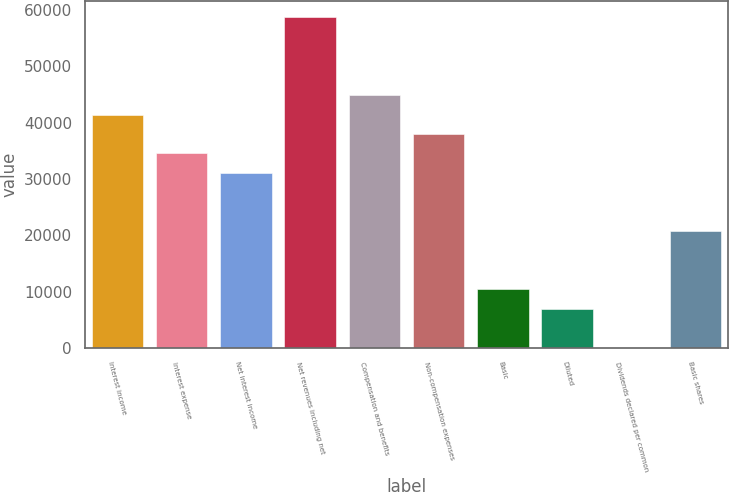<chart> <loc_0><loc_0><loc_500><loc_500><bar_chart><fcel>Interest income<fcel>Interest expense<fcel>Net interest income<fcel>Net revenues including net<fcel>Compensation and benefits<fcel>Non-compensation expenses<fcel>Basic<fcel>Diluted<fcel>Dividends declared per common<fcel>Basic shares<nl><fcel>41433.2<fcel>34528<fcel>31075.5<fcel>58696<fcel>44885.8<fcel>37980.6<fcel>10360<fcel>6907.41<fcel>2.25<fcel>20717.7<nl></chart> 